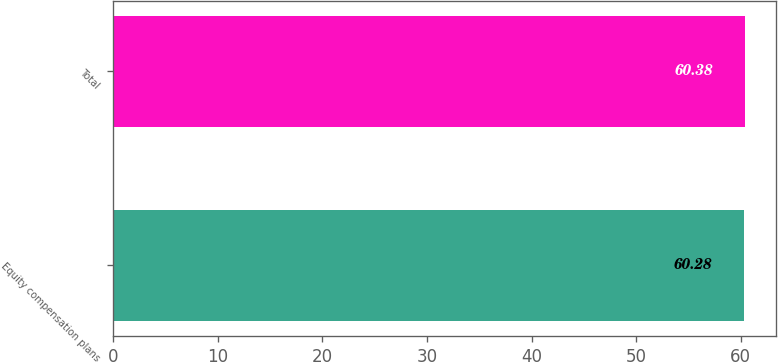<chart> <loc_0><loc_0><loc_500><loc_500><bar_chart><fcel>Equity compensation plans<fcel>Total<nl><fcel>60.28<fcel>60.38<nl></chart> 